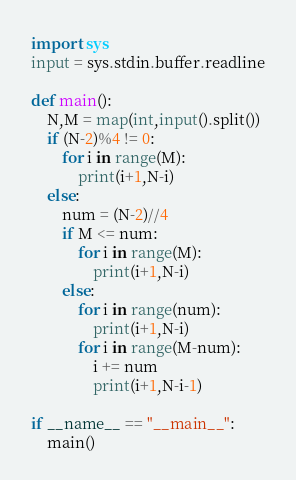<code> <loc_0><loc_0><loc_500><loc_500><_Python_>import sys
input = sys.stdin.buffer.readline

def main():
    N,M = map(int,input().split())
    if (N-2)%4 != 0:
        for i in range(M):
            print(i+1,N-i)
    else:
        num = (N-2)//4
        if M <= num:
            for i in range(M):
                print(i+1,N-i)
        else:
            for i in range(num):
                print(i+1,N-i)
            for i in range(M-num):
                i += num
                print(i+1,N-i-1)
    
if __name__ == "__main__":
    main()</code> 